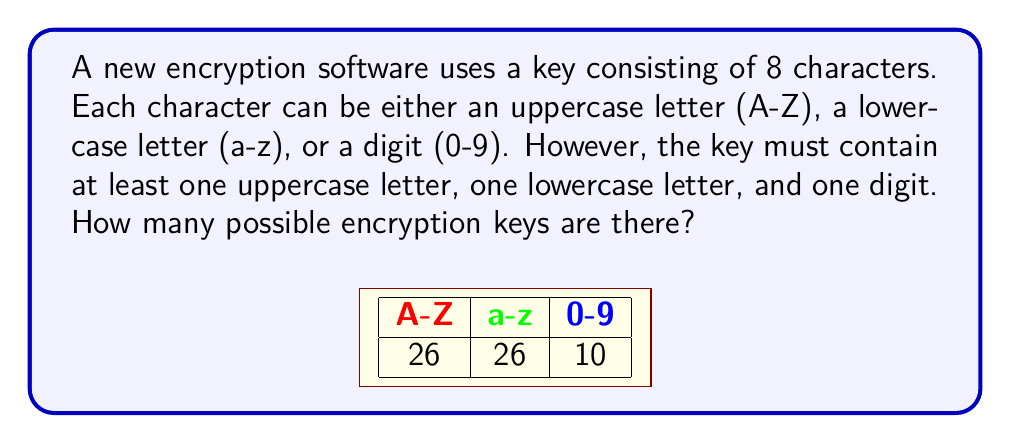Show me your answer to this math problem. Let's approach this step-by-step using the principle of inclusion-exclusion:

1) First, let's calculate the total number of 8-character strings without restrictions:
   $$(26 + 26 + 10)^8 = 62^8$$

2) Now, we need to subtract the strings that don't meet our criteria. Let's define:
   A: strings without uppercase letters
   B: strings without lowercase letters
   C: strings without digits

3) Using set notation, we want: $Total - (A \cup B \cup C)$

4) By the principle of inclusion-exclusion:
   $|A \cup B \cup C| = |A| + |B| + |C| - |A \cap B| - |A \cap C| - |B \cap C| + |A \cap B \cap C|$

5) Calculate each term:
   $|A| = 36^8$ (only lowercase and digits)
   $|B| = 36^8$ (only uppercase and digits)
   $|C| = 52^8$ (only letters)
   $|A \cap B| = 10^8$ (only digits)
   $|A \cap C| = 26^8$ (only lowercase)
   $|B \cap C| = 26^8$ (only uppercase)
   $|A \cap B \cap C| = 0$ (impossible to have none)

6) Putting it all together:
   $$62^8 - (36^8 + 36^8 + 52^8 - 10^8 - 26^8 - 26^8 + 0)$$

7) Calculating:
   $$218,340,105,584,896 - (2,821,109,907,456 + 2,821,109,907,456 + 53,459,728,531,456 - 100,000,000 - 208,827,064,576 - 208,827,064,576 + 0)$$
   $$= 218,340,105,584,896 - 58,684,948,216,216$$
   $$= 159,655,157,368,680$$
Answer: 159,655,157,368,680 